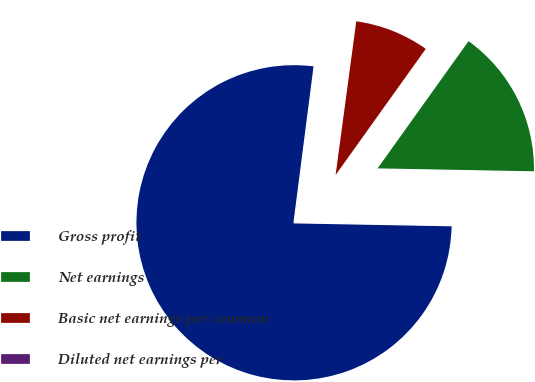Convert chart to OTSL. <chart><loc_0><loc_0><loc_500><loc_500><pie_chart><fcel>Gross profit<fcel>Net earnings<fcel>Basic net earnings per common<fcel>Diluted net earnings per<nl><fcel>76.75%<fcel>15.42%<fcel>7.75%<fcel>0.09%<nl></chart> 